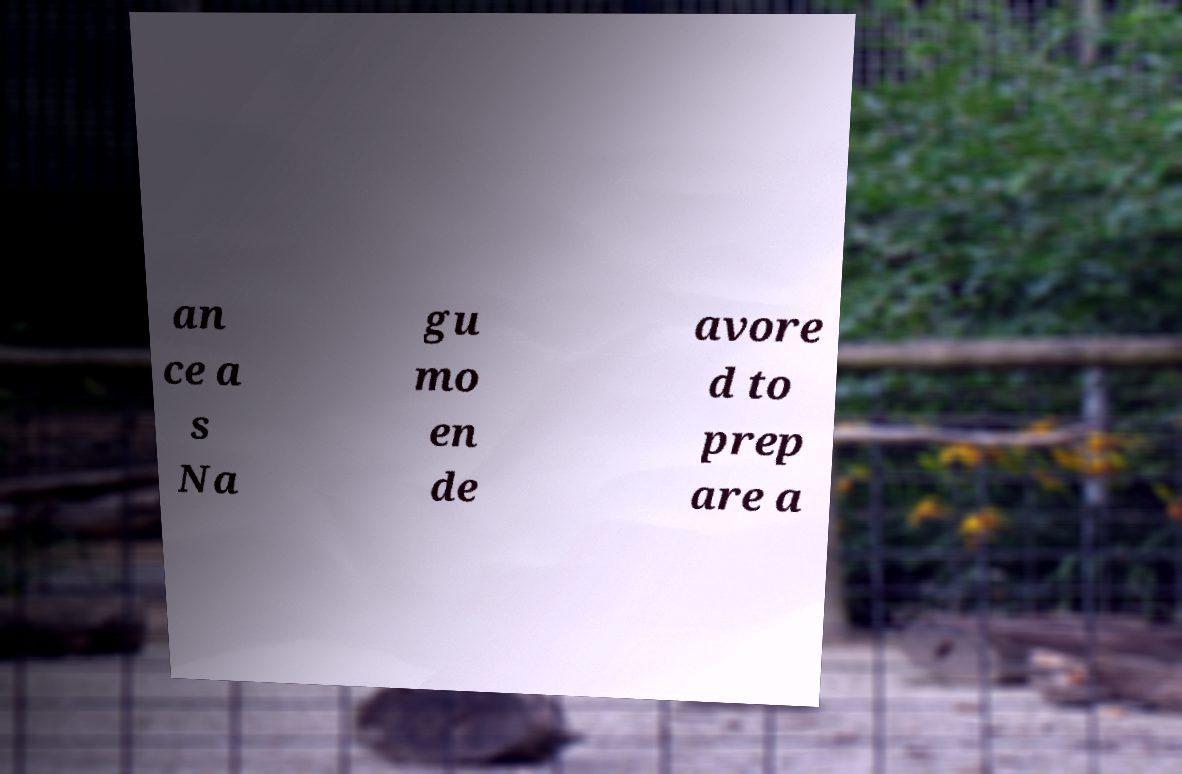I need the written content from this picture converted into text. Can you do that? an ce a s Na gu mo en de avore d to prep are a 